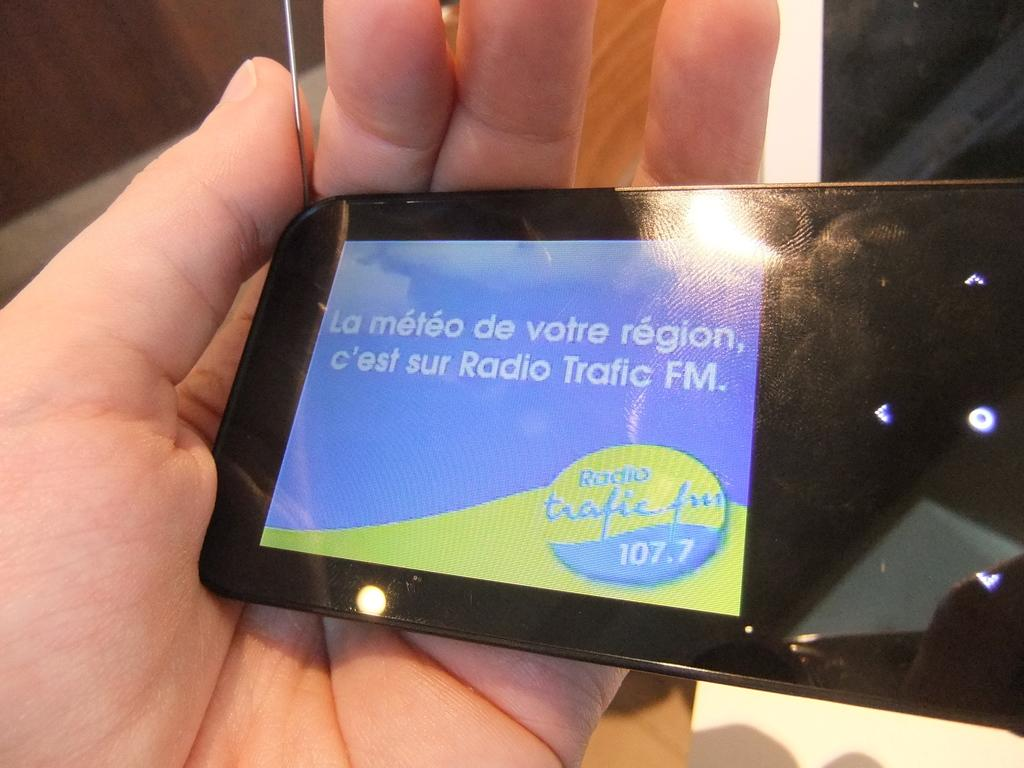<image>
Create a compact narrative representing the image presented. a blue and green image on a phone that says La Meteo 